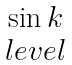Convert formula to latex. <formula><loc_0><loc_0><loc_500><loc_500>\begin{matrix} \sin k \\ l e v e l \end{matrix}</formula> 